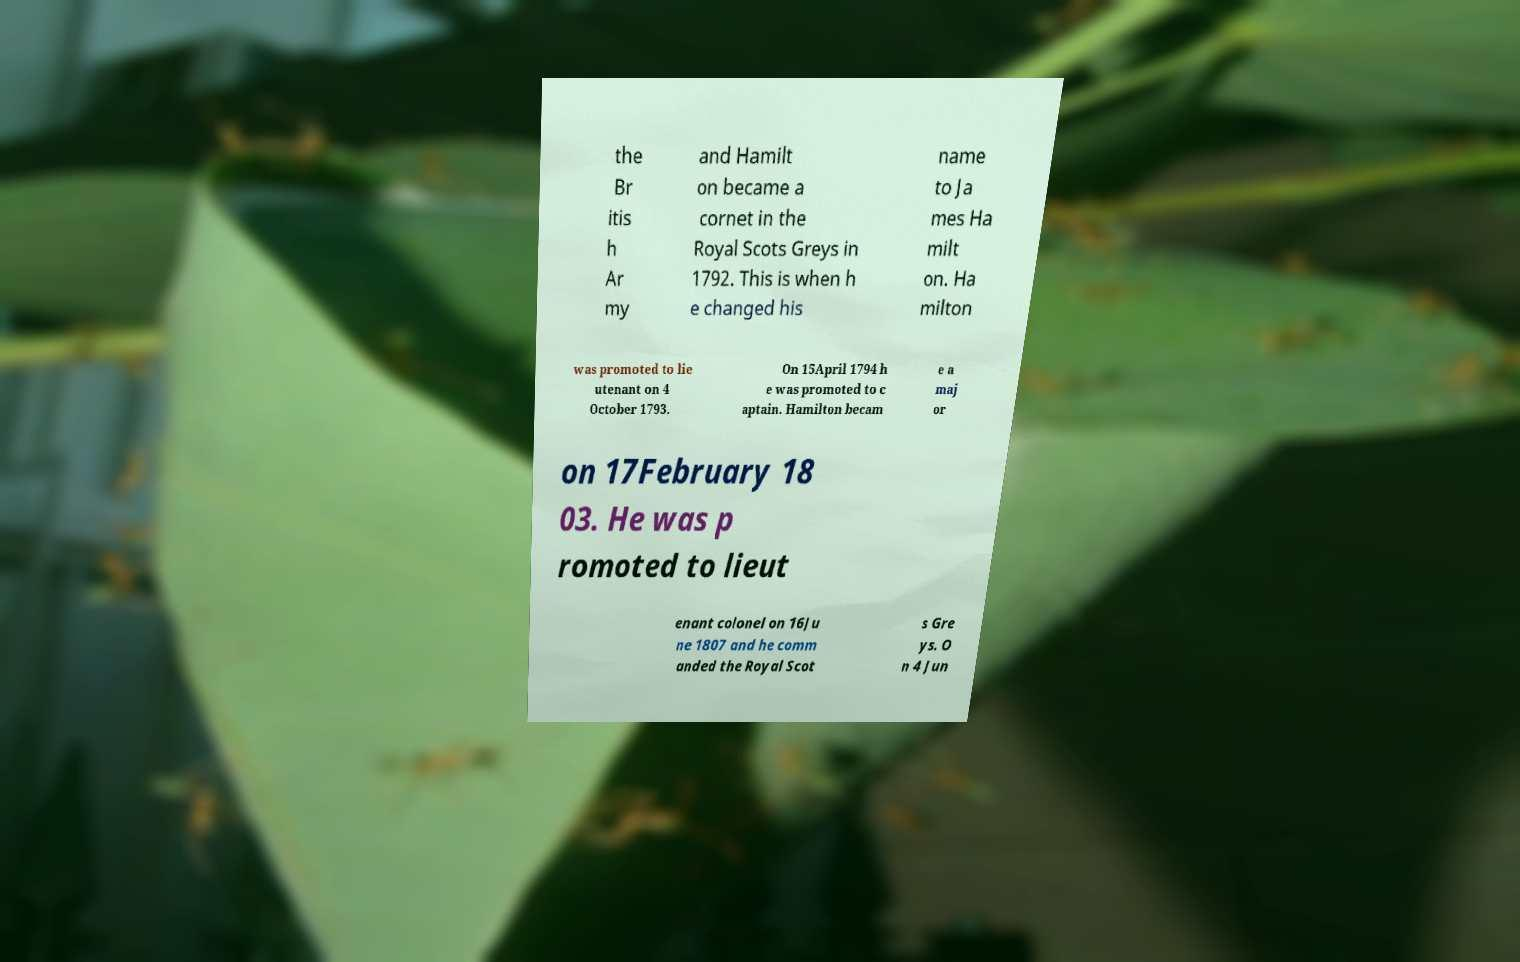Can you read and provide the text displayed in the image?This photo seems to have some interesting text. Can you extract and type it out for me? the Br itis h Ar my and Hamilt on became a cornet in the Royal Scots Greys in 1792. This is when h e changed his name to Ja mes Ha milt on. Ha milton was promoted to lie utenant on 4 October 1793. On 15April 1794 h e was promoted to c aptain. Hamilton becam e a maj or on 17February 18 03. He was p romoted to lieut enant colonel on 16Ju ne 1807 and he comm anded the Royal Scot s Gre ys. O n 4 Jun 